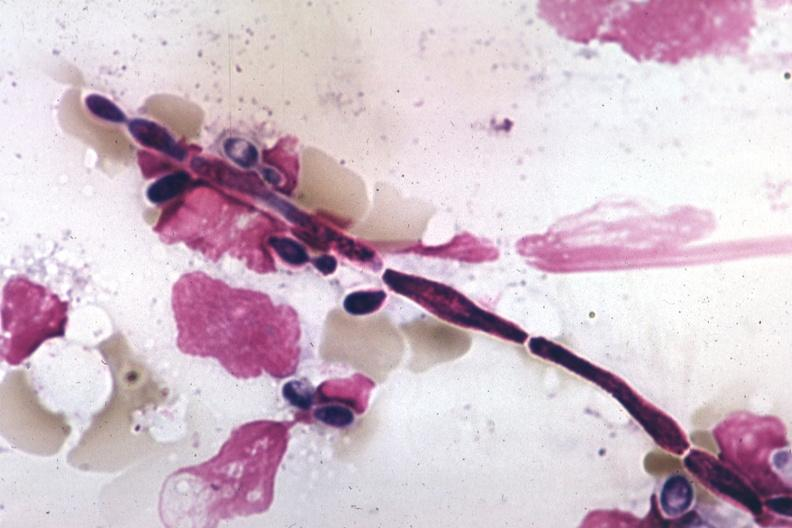what is present?
Answer the question using a single word or phrase. Candida in peripheral blood 